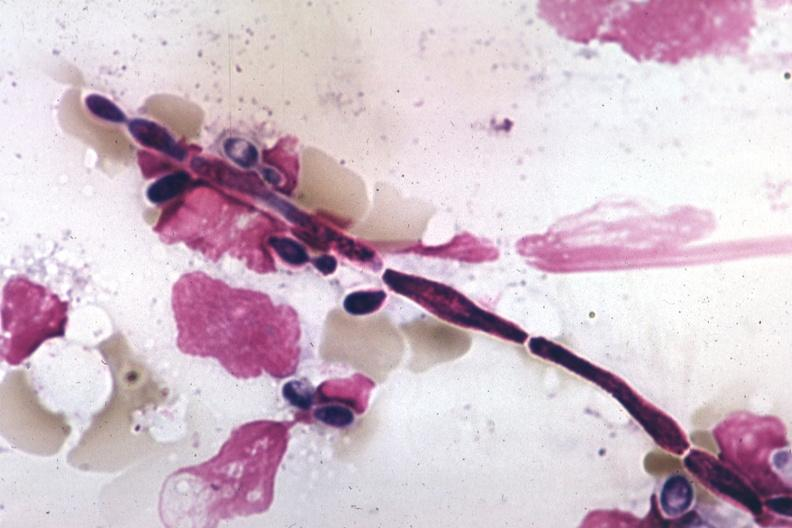what is present?
Answer the question using a single word or phrase. Candida in peripheral blood 